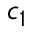<formula> <loc_0><loc_0><loc_500><loc_500>c _ { 1 }</formula> 